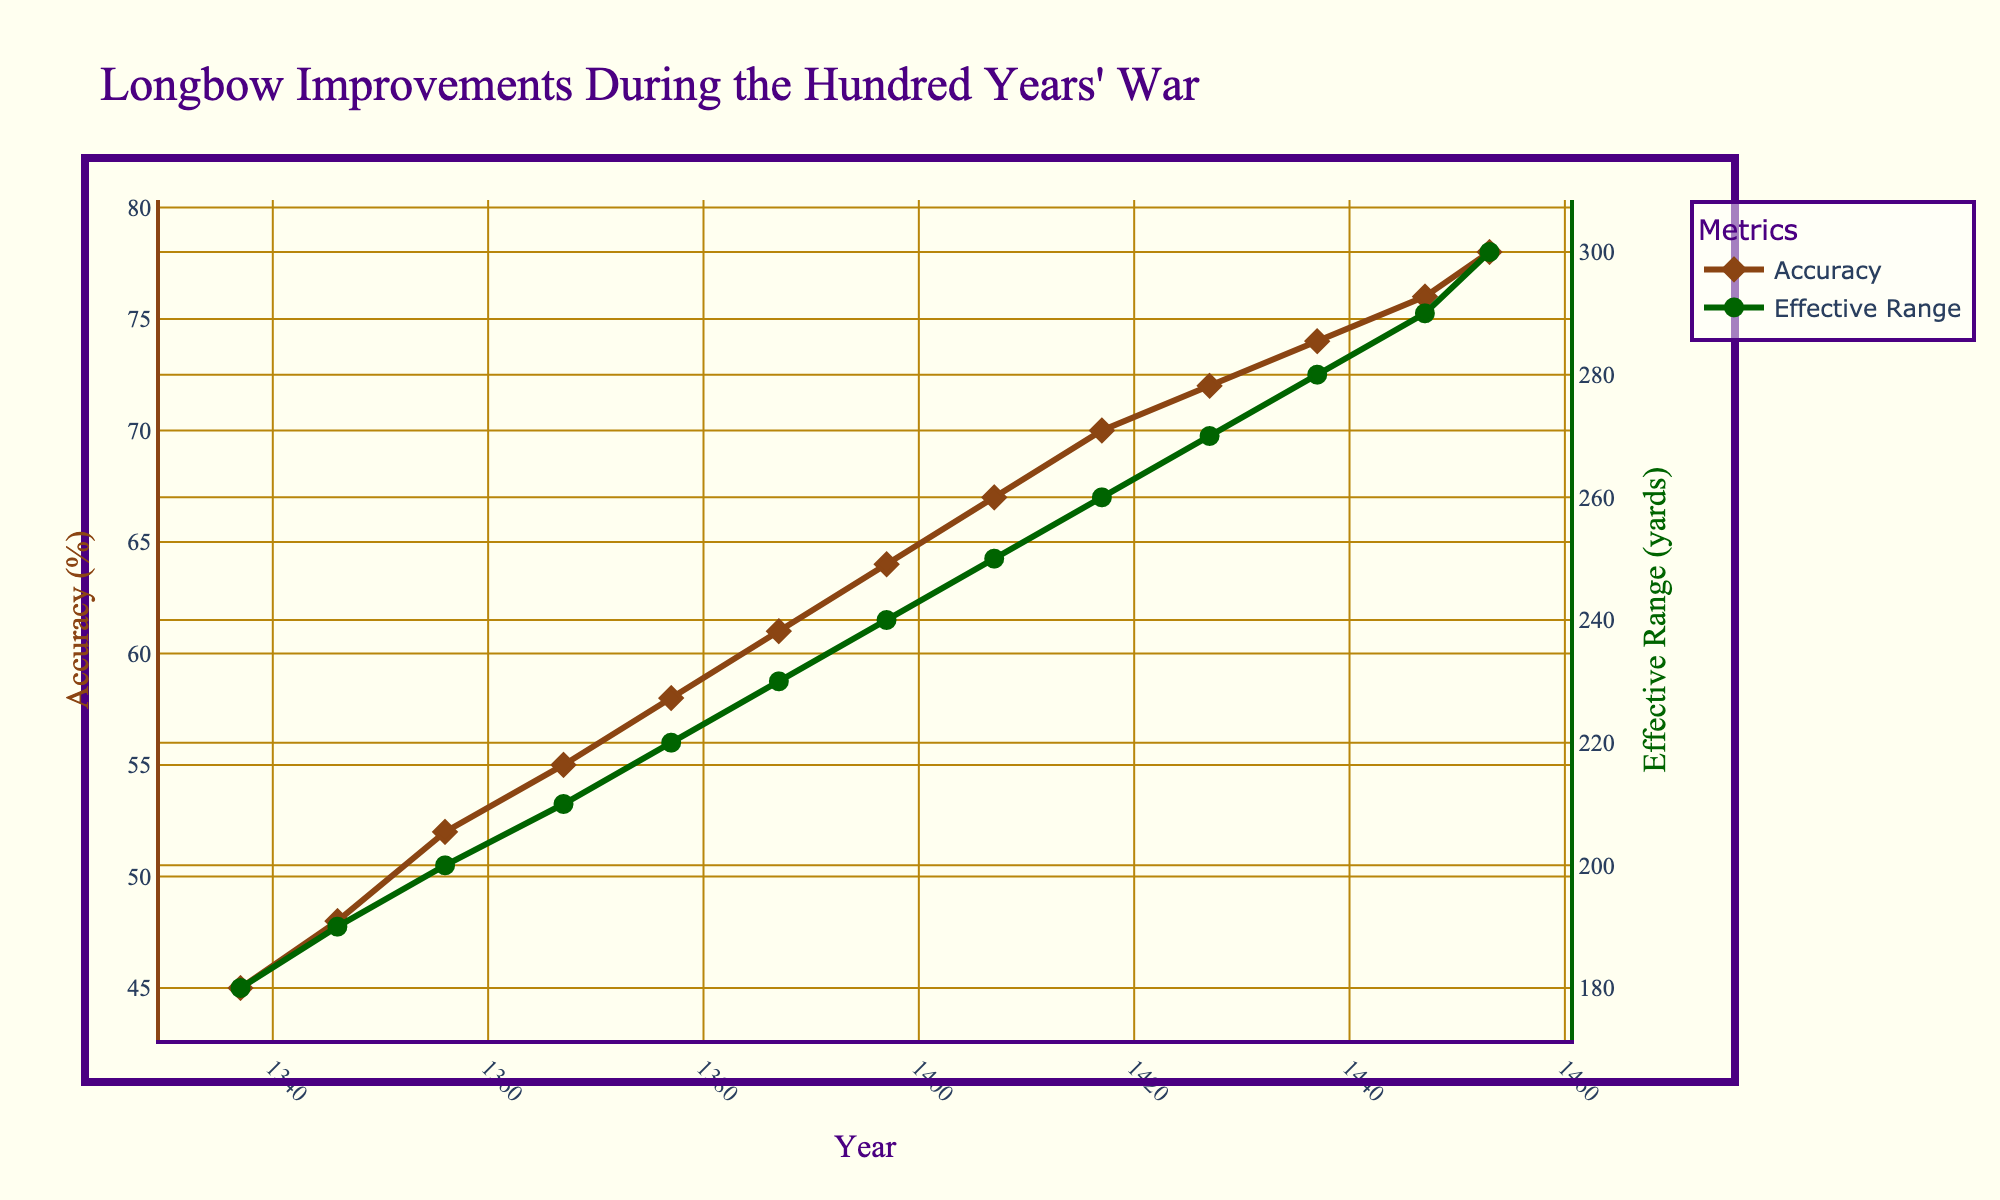What is the trend in longbow accuracy from 1337 to 1453? The longbow accuracy, depicted by the brown line, shows an increasing trend over the years. Starting from 45% in 1337, it gradually increases to 78% in 1453.
Answer: Increasing How much did the effective range of the longbow improve between 1337 and 1453? The effective range, depicted by the green line, started at 180 yards in 1337 and increased to 300 yards by 1453. The difference is calculated as 300 - 180.
Answer: 120 yards In which decade did the accuracy of the longbow surpass 60% for the first time? The brown line crosses the 60% mark between 1387 and 1397. Thus, the decade when it first surpassed 60% was 1387-1397.
Answer: 1387-1397 By how many percentage points did longbow accuracy increase from 1346 to 1407? Accuracy in 1346 was 48%, and in 1407 it was 67%. The percentage increase is calculated as 67 - 48.
Answer: 19 percentage points Which metric showed a steeper incline from 1377 to 1427: accuracy or effective range? Between 1377 and 1427, accuracy increased from 58% to 72% (an increase of 14 percentage points), while the effective range increased from 220 yards to 270 yards (an increase of 50 yards). By calculating the relative percentage increases (14/58*100 ≈ 24.14% for accuracy and 50/220*100 ≈ 22.73% for range), we see that the accuracy had a slightly steeper incline.
Answer: Accuracy What was the effective range when the accuracy was 74%? According to the chart, when accuracy reached 74% in 1437, the effective range was 280 yards.
Answer: 280 yards Did the effective range increase more in the first half or the second half of the period from 1337 to 1453? From 1337 to 1445 (first half), the range increased from 180 to 290 (an increase of 110 yards). From 1447 to 1453 (second half), the range increased from 290 to 300 (an increase of 10 yards). The increase in the first half is greater.
Answer: First half How did longbow accuracy improve from 1346 to 1447? The accuracy improved from 48% in 1346 to 76% in 1447. This is an increase of 28 percentage points over the period.
Answer: 28 percentage points 